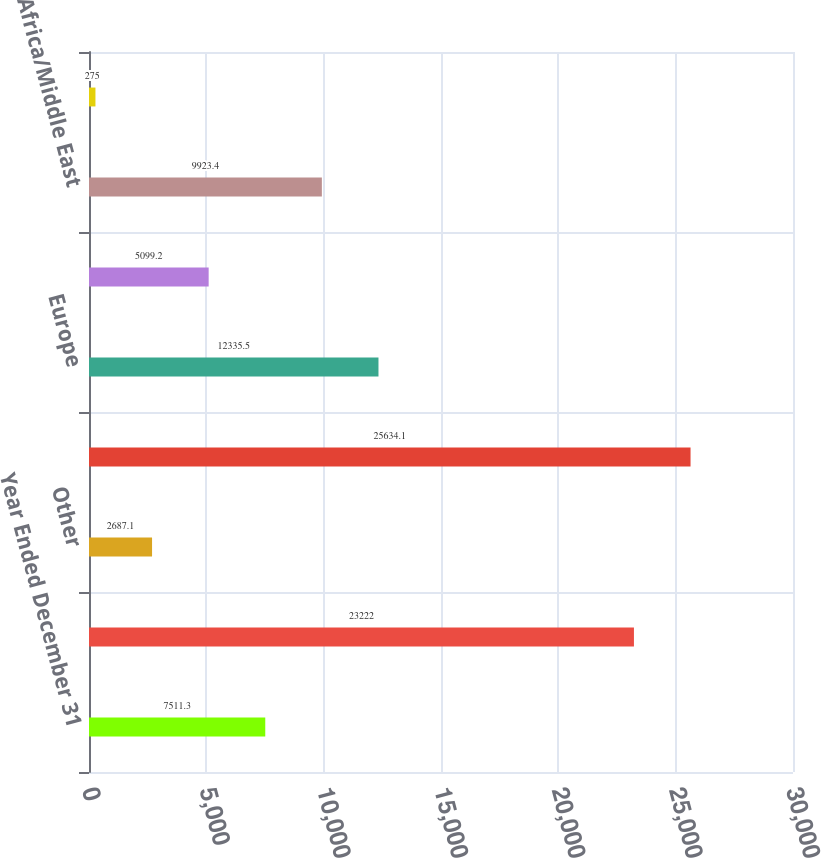Convert chart to OTSL. <chart><loc_0><loc_0><loc_500><loc_500><bar_chart><fcel>Year Ended December 31<fcel>United States<fcel>Other<fcel>Total North America<fcel>Europe<fcel>Asia/Pacific<fcel>Africa/Middle East<fcel>South America<nl><fcel>7511.3<fcel>23222<fcel>2687.1<fcel>25634.1<fcel>12335.5<fcel>5099.2<fcel>9923.4<fcel>275<nl></chart> 